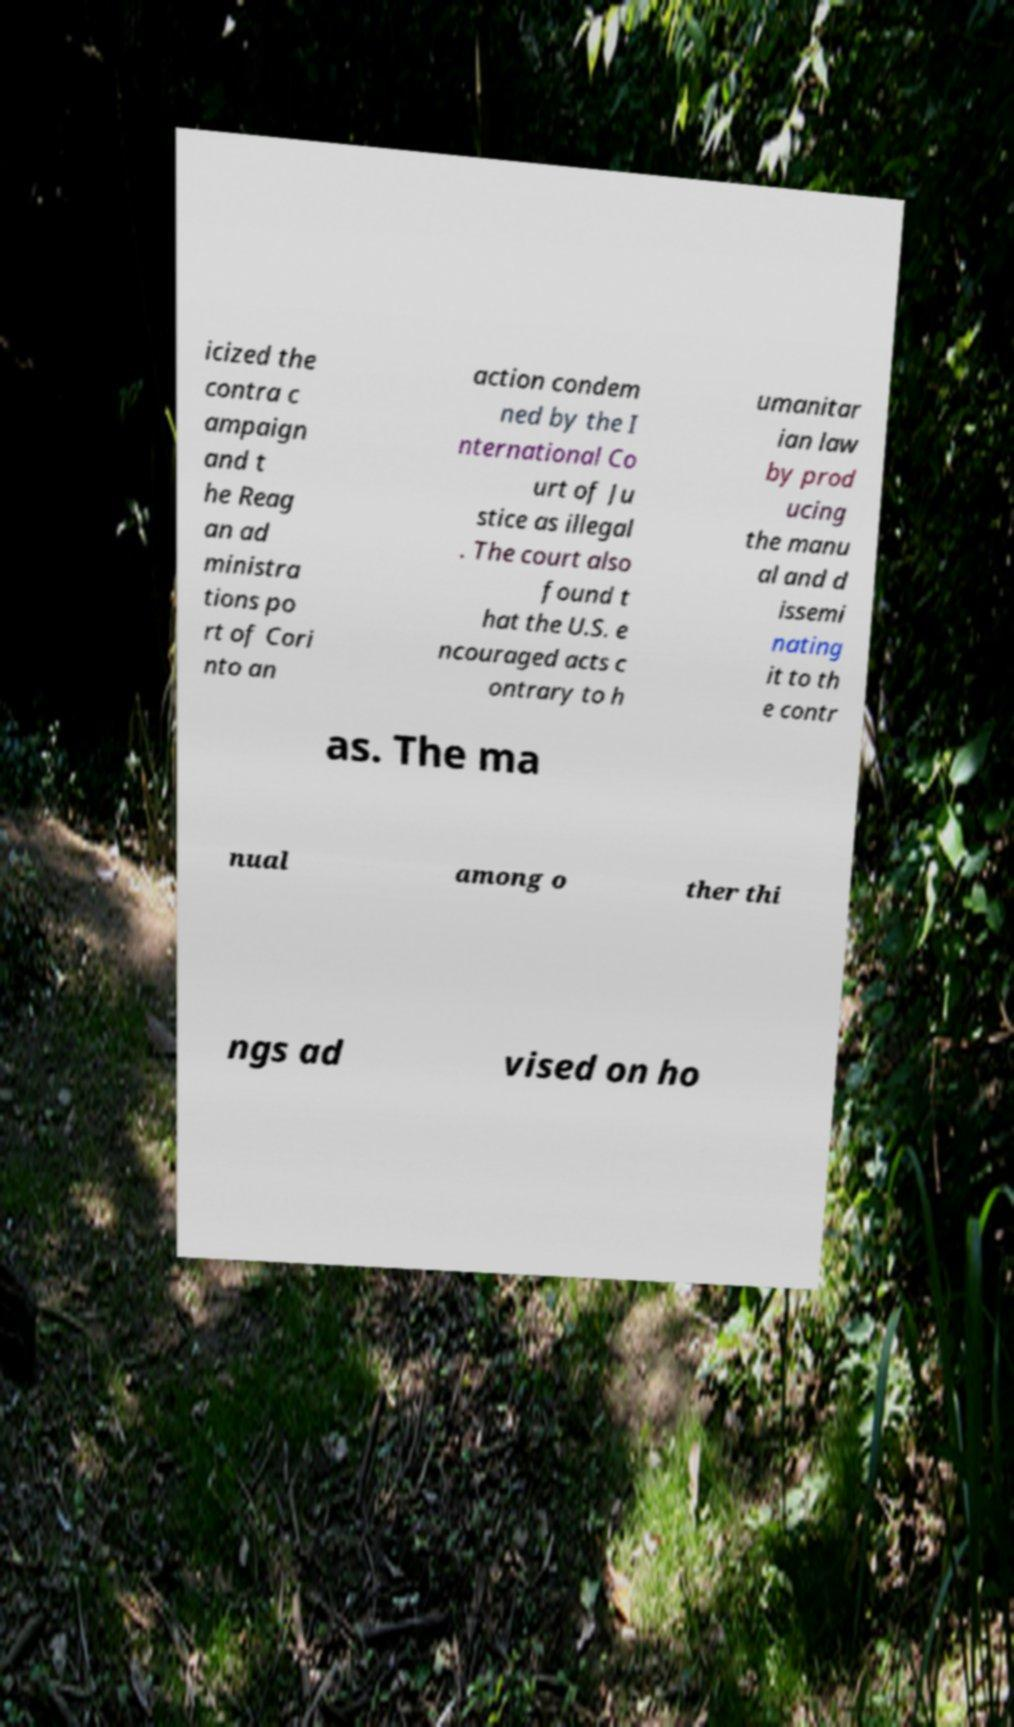For documentation purposes, I need the text within this image transcribed. Could you provide that? icized the contra c ampaign and t he Reag an ad ministra tions po rt of Cori nto an action condem ned by the I nternational Co urt of Ju stice as illegal . The court also found t hat the U.S. e ncouraged acts c ontrary to h umanitar ian law by prod ucing the manu al and d issemi nating it to th e contr as. The ma nual among o ther thi ngs ad vised on ho 